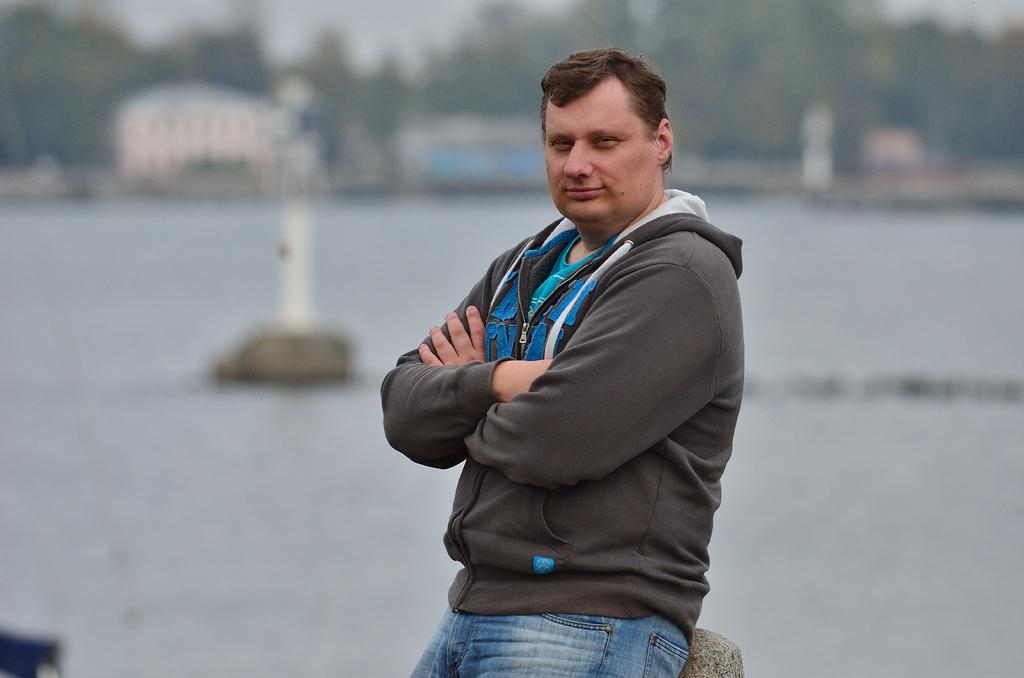Who is present in the image? There is a man in the image. What is the man's facial expression? The man is smiling. Can you describe the background of the image? The background of the image is blurry. What type of natural elements can be seen in the background? There are trees visible in the background of the image. What type of toothbrush is the man using in the image? There is no toothbrush present in the image; it features a man smiling with a blurry background. 